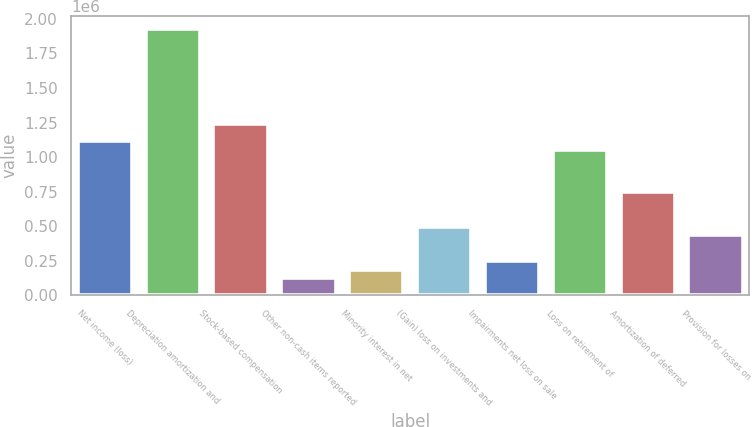Convert chart to OTSL. <chart><loc_0><loc_0><loc_500><loc_500><bar_chart><fcel>Net income (loss)<fcel>Depreciation amortization and<fcel>Stock-based compensation<fcel>Other non-cash items reported<fcel>Minority interest in net<fcel>(Gain) loss on investments and<fcel>Impairments net loss on sale<fcel>Loss on retirement of<fcel>Amortization of deferred<fcel>Provision for losses on<nl><fcel>1.11723e+06<fcel>1.92404e+06<fcel>1.24136e+06<fcel>124244<fcel>186305<fcel>496614<fcel>248367<fcel>1.05517e+06<fcel>744862<fcel>434553<nl></chart> 